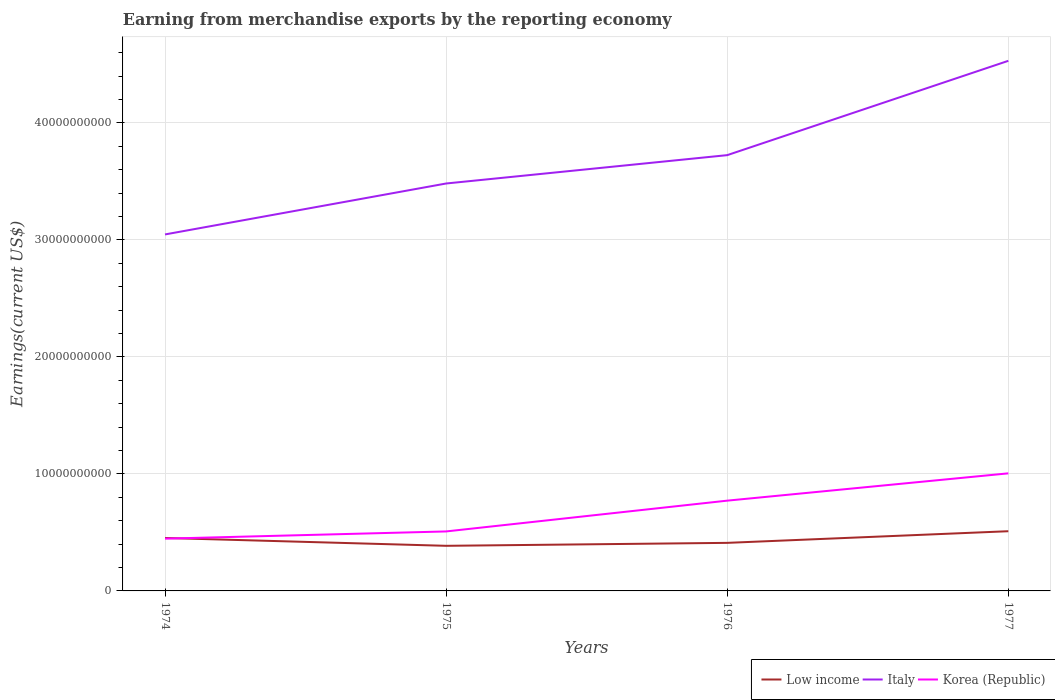How many different coloured lines are there?
Your answer should be compact. 3. Is the number of lines equal to the number of legend labels?
Make the answer very short. Yes. Across all years, what is the maximum amount earned from merchandise exports in Korea (Republic)?
Keep it short and to the point. 4.47e+09. In which year was the amount earned from merchandise exports in Italy maximum?
Provide a succinct answer. 1974. What is the total amount earned from merchandise exports in Korea (Republic) in the graph?
Give a very brief answer. -5.58e+09. What is the difference between the highest and the second highest amount earned from merchandise exports in Italy?
Provide a succinct answer. 1.48e+1. How many lines are there?
Your answer should be compact. 3. Are the values on the major ticks of Y-axis written in scientific E-notation?
Offer a terse response. No. Where does the legend appear in the graph?
Provide a short and direct response. Bottom right. How are the legend labels stacked?
Provide a short and direct response. Horizontal. What is the title of the graph?
Ensure brevity in your answer.  Earning from merchandise exports by the reporting economy. Does "Switzerland" appear as one of the legend labels in the graph?
Ensure brevity in your answer.  No. What is the label or title of the X-axis?
Your response must be concise. Years. What is the label or title of the Y-axis?
Offer a terse response. Earnings(current US$). What is the Earnings(current US$) of Low income in 1974?
Your answer should be very brief. 4.53e+09. What is the Earnings(current US$) of Italy in 1974?
Provide a succinct answer. 3.05e+1. What is the Earnings(current US$) of Korea (Republic) in 1974?
Your answer should be very brief. 4.47e+09. What is the Earnings(current US$) in Low income in 1975?
Your answer should be compact. 3.86e+09. What is the Earnings(current US$) in Italy in 1975?
Offer a terse response. 3.48e+1. What is the Earnings(current US$) of Korea (Republic) in 1975?
Give a very brief answer. 5.08e+09. What is the Earnings(current US$) of Low income in 1976?
Provide a succinct answer. 4.11e+09. What is the Earnings(current US$) of Italy in 1976?
Make the answer very short. 3.72e+1. What is the Earnings(current US$) in Korea (Republic) in 1976?
Ensure brevity in your answer.  7.71e+09. What is the Earnings(current US$) of Low income in 1977?
Provide a short and direct response. 5.10e+09. What is the Earnings(current US$) in Italy in 1977?
Make the answer very short. 4.53e+1. What is the Earnings(current US$) in Korea (Republic) in 1977?
Give a very brief answer. 1.00e+1. Across all years, what is the maximum Earnings(current US$) of Low income?
Offer a very short reply. 5.10e+09. Across all years, what is the maximum Earnings(current US$) of Italy?
Provide a succinct answer. 4.53e+1. Across all years, what is the maximum Earnings(current US$) of Korea (Republic)?
Offer a terse response. 1.00e+1. Across all years, what is the minimum Earnings(current US$) of Low income?
Offer a very short reply. 3.86e+09. Across all years, what is the minimum Earnings(current US$) of Italy?
Provide a succinct answer. 3.05e+1. Across all years, what is the minimum Earnings(current US$) in Korea (Republic)?
Offer a terse response. 4.47e+09. What is the total Earnings(current US$) of Low income in the graph?
Your answer should be compact. 1.76e+1. What is the total Earnings(current US$) in Italy in the graph?
Provide a succinct answer. 1.48e+11. What is the total Earnings(current US$) in Korea (Republic) in the graph?
Keep it short and to the point. 2.73e+1. What is the difference between the Earnings(current US$) of Low income in 1974 and that in 1975?
Give a very brief answer. 6.70e+08. What is the difference between the Earnings(current US$) in Italy in 1974 and that in 1975?
Make the answer very short. -4.35e+09. What is the difference between the Earnings(current US$) in Korea (Republic) in 1974 and that in 1975?
Keep it short and to the point. -6.17e+08. What is the difference between the Earnings(current US$) of Low income in 1974 and that in 1976?
Offer a terse response. 4.18e+08. What is the difference between the Earnings(current US$) of Italy in 1974 and that in 1976?
Offer a very short reply. -6.78e+09. What is the difference between the Earnings(current US$) of Korea (Republic) in 1974 and that in 1976?
Make the answer very short. -3.25e+09. What is the difference between the Earnings(current US$) of Low income in 1974 and that in 1977?
Offer a very short reply. -5.77e+08. What is the difference between the Earnings(current US$) of Italy in 1974 and that in 1977?
Keep it short and to the point. -1.48e+1. What is the difference between the Earnings(current US$) of Korea (Republic) in 1974 and that in 1977?
Provide a short and direct response. -5.58e+09. What is the difference between the Earnings(current US$) of Low income in 1975 and that in 1976?
Keep it short and to the point. -2.51e+08. What is the difference between the Earnings(current US$) of Italy in 1975 and that in 1976?
Give a very brief answer. -2.42e+09. What is the difference between the Earnings(current US$) of Korea (Republic) in 1975 and that in 1976?
Ensure brevity in your answer.  -2.63e+09. What is the difference between the Earnings(current US$) of Low income in 1975 and that in 1977?
Offer a very short reply. -1.25e+09. What is the difference between the Earnings(current US$) of Italy in 1975 and that in 1977?
Provide a succinct answer. -1.05e+1. What is the difference between the Earnings(current US$) in Korea (Republic) in 1975 and that in 1977?
Keep it short and to the point. -4.96e+09. What is the difference between the Earnings(current US$) of Low income in 1976 and that in 1977?
Offer a terse response. -9.96e+08. What is the difference between the Earnings(current US$) in Italy in 1976 and that in 1977?
Offer a very short reply. -8.06e+09. What is the difference between the Earnings(current US$) in Korea (Republic) in 1976 and that in 1977?
Make the answer very short. -2.33e+09. What is the difference between the Earnings(current US$) in Low income in 1974 and the Earnings(current US$) in Italy in 1975?
Provide a succinct answer. -3.03e+1. What is the difference between the Earnings(current US$) of Low income in 1974 and the Earnings(current US$) of Korea (Republic) in 1975?
Offer a very short reply. -5.59e+08. What is the difference between the Earnings(current US$) in Italy in 1974 and the Earnings(current US$) in Korea (Republic) in 1975?
Offer a very short reply. 2.54e+1. What is the difference between the Earnings(current US$) in Low income in 1974 and the Earnings(current US$) in Italy in 1976?
Offer a terse response. -3.27e+1. What is the difference between the Earnings(current US$) in Low income in 1974 and the Earnings(current US$) in Korea (Republic) in 1976?
Offer a terse response. -3.19e+09. What is the difference between the Earnings(current US$) in Italy in 1974 and the Earnings(current US$) in Korea (Republic) in 1976?
Provide a short and direct response. 2.28e+1. What is the difference between the Earnings(current US$) in Low income in 1974 and the Earnings(current US$) in Italy in 1977?
Provide a succinct answer. -4.08e+1. What is the difference between the Earnings(current US$) in Low income in 1974 and the Earnings(current US$) in Korea (Republic) in 1977?
Keep it short and to the point. -5.52e+09. What is the difference between the Earnings(current US$) in Italy in 1974 and the Earnings(current US$) in Korea (Republic) in 1977?
Offer a terse response. 2.04e+1. What is the difference between the Earnings(current US$) of Low income in 1975 and the Earnings(current US$) of Italy in 1976?
Ensure brevity in your answer.  -3.34e+1. What is the difference between the Earnings(current US$) in Low income in 1975 and the Earnings(current US$) in Korea (Republic) in 1976?
Keep it short and to the point. -3.86e+09. What is the difference between the Earnings(current US$) in Italy in 1975 and the Earnings(current US$) in Korea (Republic) in 1976?
Offer a very short reply. 2.71e+1. What is the difference between the Earnings(current US$) in Low income in 1975 and the Earnings(current US$) in Italy in 1977?
Your response must be concise. -4.14e+1. What is the difference between the Earnings(current US$) of Low income in 1975 and the Earnings(current US$) of Korea (Republic) in 1977?
Provide a succinct answer. -6.19e+09. What is the difference between the Earnings(current US$) of Italy in 1975 and the Earnings(current US$) of Korea (Republic) in 1977?
Give a very brief answer. 2.48e+1. What is the difference between the Earnings(current US$) of Low income in 1976 and the Earnings(current US$) of Italy in 1977?
Keep it short and to the point. -4.12e+1. What is the difference between the Earnings(current US$) in Low income in 1976 and the Earnings(current US$) in Korea (Republic) in 1977?
Offer a very short reply. -5.94e+09. What is the difference between the Earnings(current US$) in Italy in 1976 and the Earnings(current US$) in Korea (Republic) in 1977?
Provide a short and direct response. 2.72e+1. What is the average Earnings(current US$) of Low income per year?
Keep it short and to the point. 4.40e+09. What is the average Earnings(current US$) in Italy per year?
Offer a terse response. 3.70e+1. What is the average Earnings(current US$) in Korea (Republic) per year?
Offer a very short reply. 6.83e+09. In the year 1974, what is the difference between the Earnings(current US$) of Low income and Earnings(current US$) of Italy?
Your answer should be compact. -2.59e+1. In the year 1974, what is the difference between the Earnings(current US$) of Low income and Earnings(current US$) of Korea (Republic)?
Your response must be concise. 5.89e+07. In the year 1974, what is the difference between the Earnings(current US$) in Italy and Earnings(current US$) in Korea (Republic)?
Offer a terse response. 2.60e+1. In the year 1975, what is the difference between the Earnings(current US$) of Low income and Earnings(current US$) of Italy?
Your response must be concise. -3.10e+1. In the year 1975, what is the difference between the Earnings(current US$) of Low income and Earnings(current US$) of Korea (Republic)?
Your response must be concise. -1.23e+09. In the year 1975, what is the difference between the Earnings(current US$) of Italy and Earnings(current US$) of Korea (Republic)?
Provide a succinct answer. 2.97e+1. In the year 1976, what is the difference between the Earnings(current US$) in Low income and Earnings(current US$) in Italy?
Your answer should be compact. -3.31e+1. In the year 1976, what is the difference between the Earnings(current US$) in Low income and Earnings(current US$) in Korea (Republic)?
Provide a succinct answer. -3.61e+09. In the year 1976, what is the difference between the Earnings(current US$) of Italy and Earnings(current US$) of Korea (Republic)?
Offer a terse response. 2.95e+1. In the year 1977, what is the difference between the Earnings(current US$) of Low income and Earnings(current US$) of Italy?
Make the answer very short. -4.02e+1. In the year 1977, what is the difference between the Earnings(current US$) in Low income and Earnings(current US$) in Korea (Republic)?
Your response must be concise. -4.95e+09. In the year 1977, what is the difference between the Earnings(current US$) of Italy and Earnings(current US$) of Korea (Republic)?
Your answer should be very brief. 3.53e+1. What is the ratio of the Earnings(current US$) of Low income in 1974 to that in 1975?
Your response must be concise. 1.17. What is the ratio of the Earnings(current US$) of Korea (Republic) in 1974 to that in 1975?
Ensure brevity in your answer.  0.88. What is the ratio of the Earnings(current US$) in Low income in 1974 to that in 1976?
Offer a very short reply. 1.1. What is the ratio of the Earnings(current US$) in Italy in 1974 to that in 1976?
Your answer should be compact. 0.82. What is the ratio of the Earnings(current US$) in Korea (Republic) in 1974 to that in 1976?
Ensure brevity in your answer.  0.58. What is the ratio of the Earnings(current US$) of Low income in 1974 to that in 1977?
Give a very brief answer. 0.89. What is the ratio of the Earnings(current US$) in Italy in 1974 to that in 1977?
Provide a short and direct response. 0.67. What is the ratio of the Earnings(current US$) of Korea (Republic) in 1974 to that in 1977?
Your answer should be compact. 0.44. What is the ratio of the Earnings(current US$) of Low income in 1975 to that in 1976?
Offer a very short reply. 0.94. What is the ratio of the Earnings(current US$) in Italy in 1975 to that in 1976?
Ensure brevity in your answer.  0.93. What is the ratio of the Earnings(current US$) of Korea (Republic) in 1975 to that in 1976?
Your answer should be very brief. 0.66. What is the ratio of the Earnings(current US$) of Low income in 1975 to that in 1977?
Your response must be concise. 0.76. What is the ratio of the Earnings(current US$) in Italy in 1975 to that in 1977?
Provide a short and direct response. 0.77. What is the ratio of the Earnings(current US$) of Korea (Republic) in 1975 to that in 1977?
Offer a very short reply. 0.51. What is the ratio of the Earnings(current US$) in Low income in 1976 to that in 1977?
Provide a succinct answer. 0.8. What is the ratio of the Earnings(current US$) in Italy in 1976 to that in 1977?
Your answer should be very brief. 0.82. What is the ratio of the Earnings(current US$) of Korea (Republic) in 1976 to that in 1977?
Offer a very short reply. 0.77. What is the difference between the highest and the second highest Earnings(current US$) of Low income?
Your response must be concise. 5.77e+08. What is the difference between the highest and the second highest Earnings(current US$) in Italy?
Your answer should be compact. 8.06e+09. What is the difference between the highest and the second highest Earnings(current US$) in Korea (Republic)?
Your response must be concise. 2.33e+09. What is the difference between the highest and the lowest Earnings(current US$) in Low income?
Your response must be concise. 1.25e+09. What is the difference between the highest and the lowest Earnings(current US$) in Italy?
Offer a terse response. 1.48e+1. What is the difference between the highest and the lowest Earnings(current US$) in Korea (Republic)?
Give a very brief answer. 5.58e+09. 